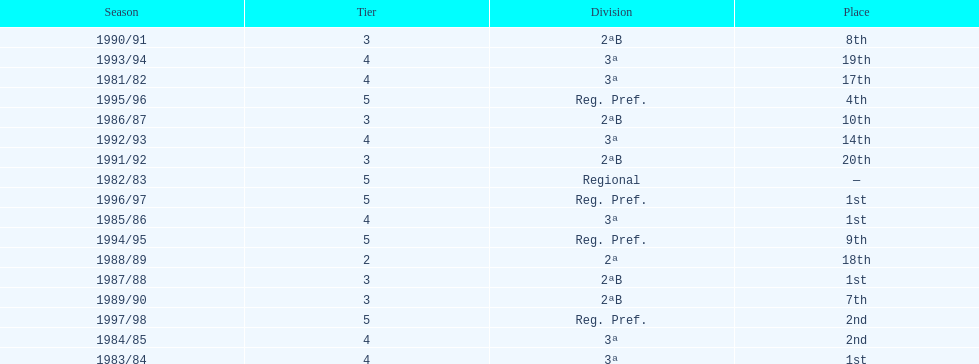In which year did the team have its worst season? 1991/92. 